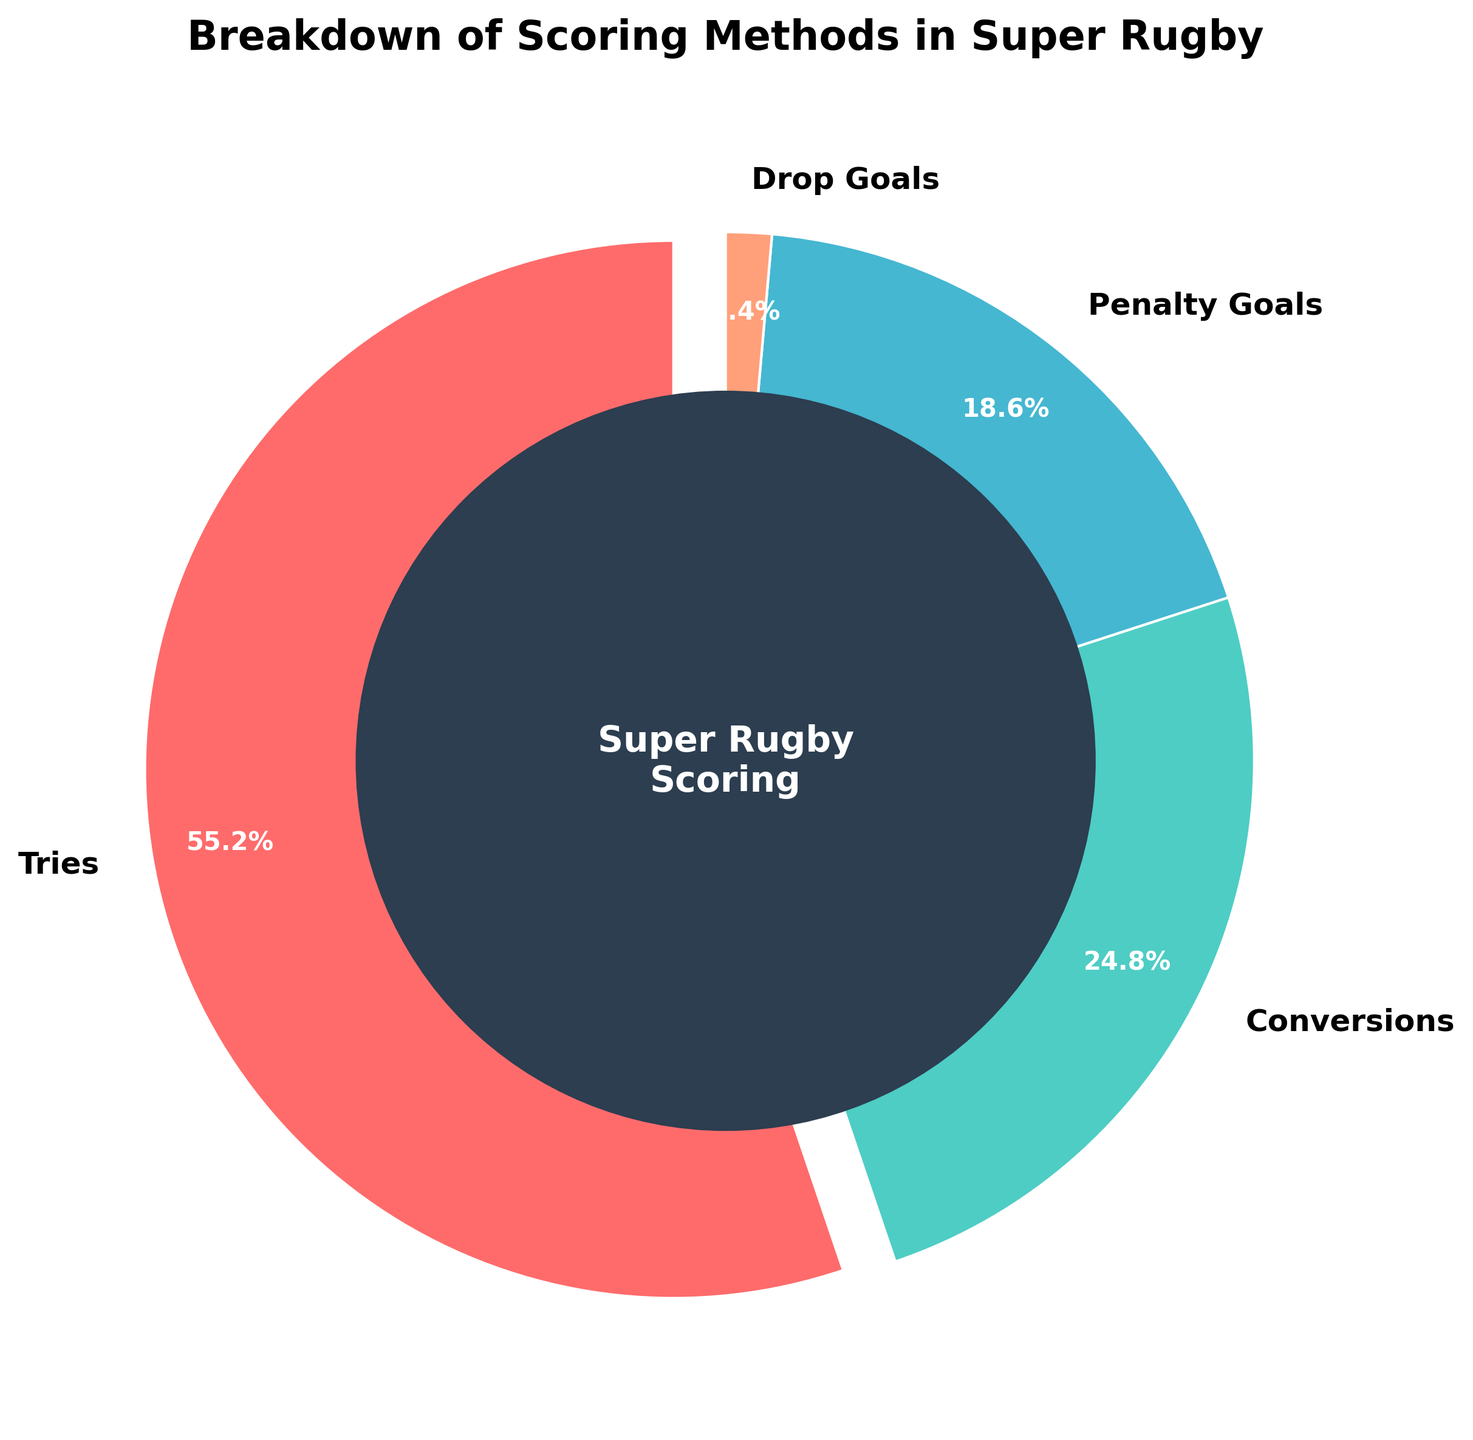What percentage of scoring methods in Super Rugby are tries? From the pie chart, we see the label for tries shows 55.2%, indicating that tries account for 55.2% of the scoring methods.
Answer: 55.2% Which scoring method contributes the least to the total score? By looking at the percentages on the pie chart, Drop Goals have the smallest slice with 1.4%, making it the least contributory scoring method.
Answer: Drop Goals What is the total percentage of scoring methods that are not Tries? To find this, subtract the percentage of tries from 100: 100 - 55.2 = 44.8. This includes Conversions, Penalty Goals, and Drop Goals.
Answer: 44.8% Are penalty goals a more common scoring method than conversions? The pie chart shows percentages for both conversions (24.8%) and penalty goals (18.6%). Since 24.8% is greater than 18.6%, conversions are more common.
Answer: No How many times larger is the percentage of tries compared to drop goals? Divide the percentage for tries by the percentage for drop goals: 55.2 / 1.4 = 39.4. So, tries are 39.4 times larger in percentage than drop goals.
Answer: 39.4 times What is the combined percentage for penalty goals and drop goals? Add the percentages for penalty goals and drop goals: 18.6 + 1.4 = 20.0.
Answer: 20.0% How does the percentage of penalty goals compare with conversions? Conversions have a percentage of 24.8% and penalty goals have 18.6%. Since 24.8 is greater than 18.6, conversions are more frequent.
Answer: Conversions are higher What color represents penalty goals in the pie chart? From the given color list and their respective order, the third color (orange-like) represents penalty goals, which is labeled 18.6% on the pie chart.
Answer: Orange What's the difference in percentage between tries and penalty goals? Subtract the percentage of penalty goals from tries: 55.2 - 18.6 = 36.6.
Answer: 36.6% What scoring method is represented by the largest slice on the pie chart? The largest slice on the pie chart, visually and by percentage, represents tries at 55.2%.
Answer: Tries 